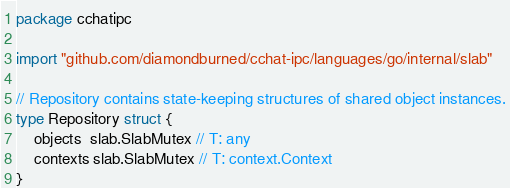<code> <loc_0><loc_0><loc_500><loc_500><_Go_>package cchatipc

import "github.com/diamondburned/cchat-ipc/languages/go/internal/slab"

// Repository contains state-keeping structures of shared object instances.
type Repository struct {
	objects  slab.SlabMutex // T: any
	contexts slab.SlabMutex // T: context.Context
}
</code> 